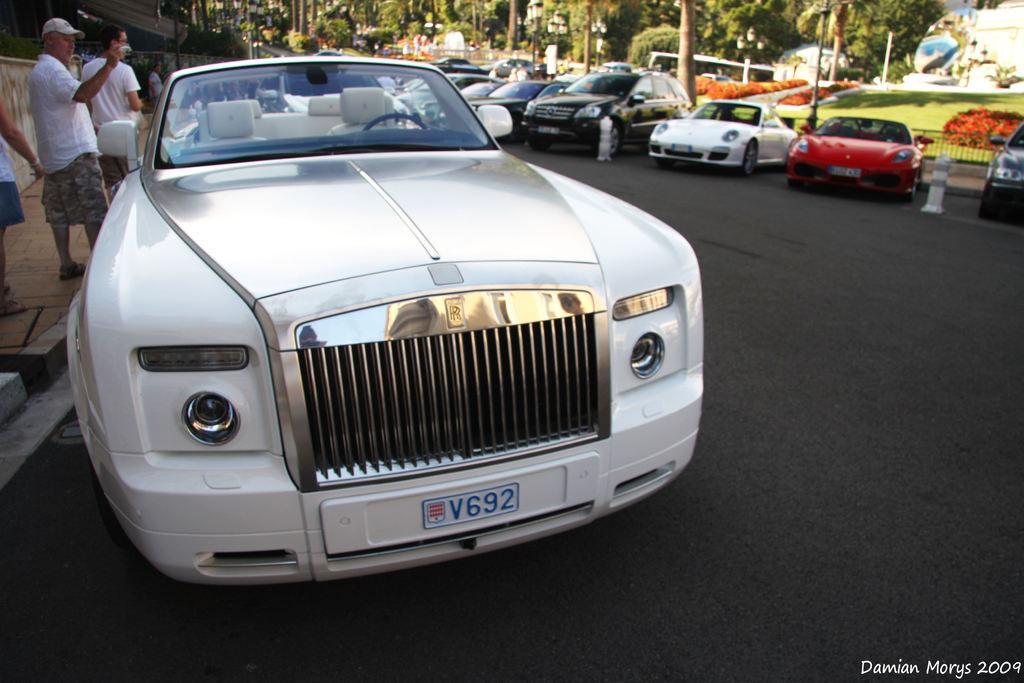Can you describe this image briefly? In this image we can see some buildings, some lights with poles, some people are walking, some people are standing, two white poles on the road, some vehicles on the road, some object on the ground, one fence, on footpath, some text on the bottom right side corner of the image, some people are holding some objects, some plants with flowers, some trees, bushes, plants and grass on the ground. 